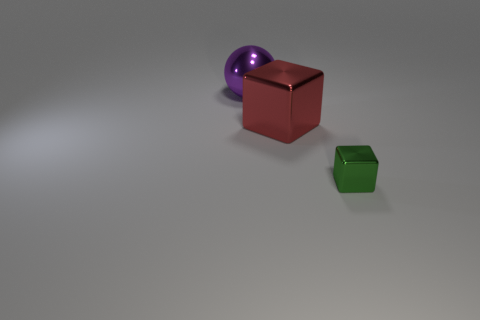Subtract all green blocks. How many blocks are left? 1 Add 1 purple metal objects. How many objects exist? 4 Subtract all spheres. How many objects are left? 2 Subtract 1 cubes. How many cubes are left? 1 Add 1 tiny metallic objects. How many tiny metallic objects exist? 2 Subtract 1 green cubes. How many objects are left? 2 Subtract all blue cubes. Subtract all cyan cylinders. How many cubes are left? 2 Subtract all green spheres. How many yellow cubes are left? 0 Subtract all blue shiny balls. Subtract all large things. How many objects are left? 1 Add 1 purple balls. How many purple balls are left? 2 